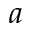<formula> <loc_0><loc_0><loc_500><loc_500>a</formula> 